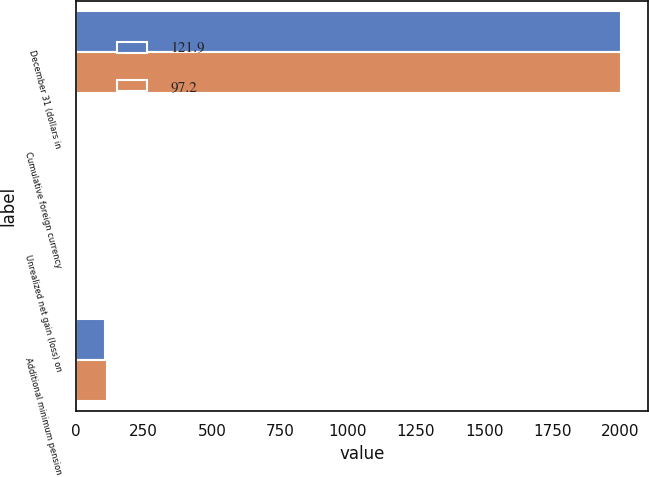<chart> <loc_0><loc_0><loc_500><loc_500><stacked_bar_chart><ecel><fcel>December 31 (dollars in<fcel>Cumulative foreign currency<fcel>Unrealized net gain (loss) on<fcel>Additional minimum pension<nl><fcel>121.9<fcel>2003<fcel>0.8<fcel>9.3<fcel>107.3<nl><fcel>97.2<fcel>2002<fcel>3.4<fcel>3.8<fcel>114.7<nl></chart> 